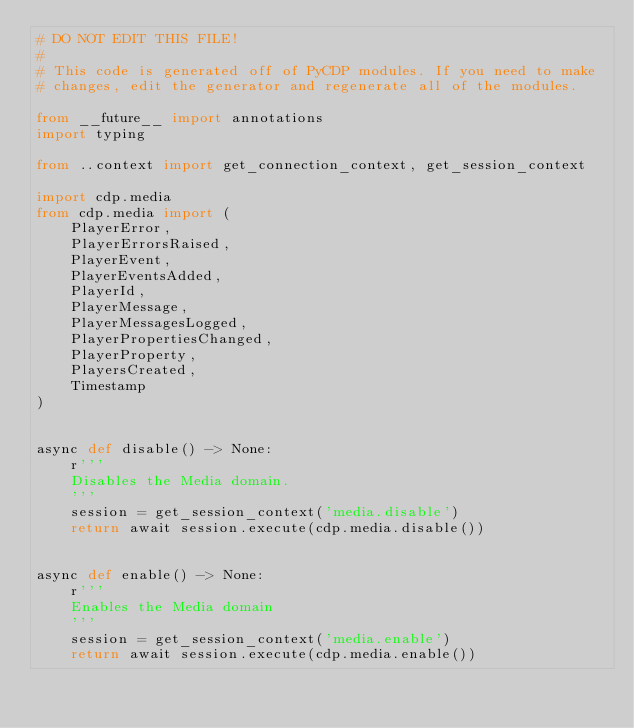<code> <loc_0><loc_0><loc_500><loc_500><_Python_># DO NOT EDIT THIS FILE!
#
# This code is generated off of PyCDP modules. If you need to make
# changes, edit the generator and regenerate all of the modules.

from __future__ import annotations
import typing

from ..context import get_connection_context, get_session_context

import cdp.media
from cdp.media import (
    PlayerError,
    PlayerErrorsRaised,
    PlayerEvent,
    PlayerEventsAdded,
    PlayerId,
    PlayerMessage,
    PlayerMessagesLogged,
    PlayerPropertiesChanged,
    PlayerProperty,
    PlayersCreated,
    Timestamp
)


async def disable() -> None:
    r'''
    Disables the Media domain.
    '''
    session = get_session_context('media.disable')
    return await session.execute(cdp.media.disable())


async def enable() -> None:
    r'''
    Enables the Media domain
    '''
    session = get_session_context('media.enable')
    return await session.execute(cdp.media.enable())
</code> 